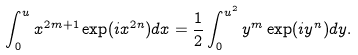<formula> <loc_0><loc_0><loc_500><loc_500>\int _ { 0 } ^ { u } x ^ { 2 m + 1 } \exp ( i x ^ { 2 n } ) d x = \frac { 1 } { 2 } \int _ { 0 } ^ { u ^ { 2 } } y ^ { m } \exp ( i y ^ { n } ) d y .</formula> 